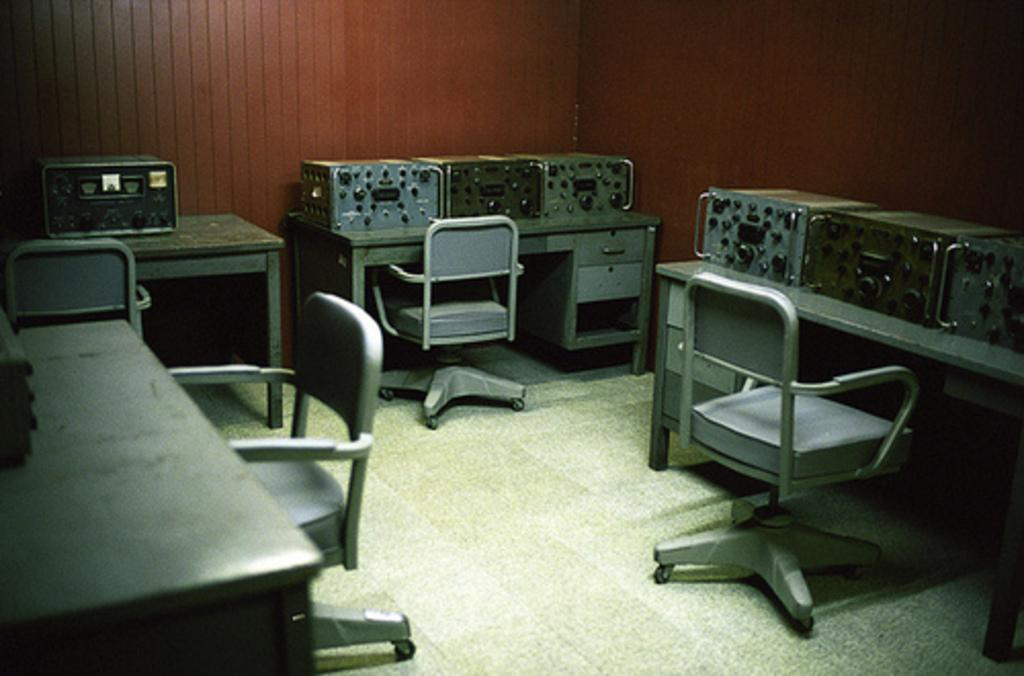What can be seen on the tables in the image? There are equipment on the tables in the image. How many chairs are there in front of each table? There is at least one chair in front of each table in the image. What type of seed can be seen growing on the chairs in the image? There are no seeds or plants growing on the chairs in the image. 